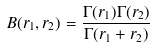<formula> <loc_0><loc_0><loc_500><loc_500>B ( r _ { 1 } , r _ { 2 } ) = \frac { \Gamma ( r _ { 1 } ) \Gamma ( r _ { 2 } ) } { \Gamma ( r _ { 1 } + r _ { 2 } ) }</formula> 